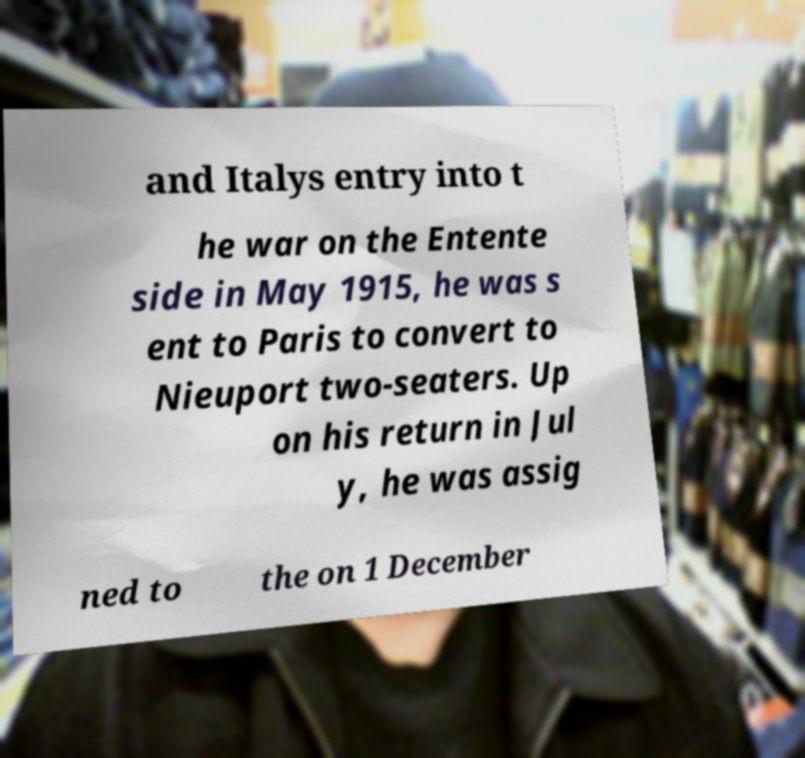I need the written content from this picture converted into text. Can you do that? and Italys entry into t he war on the Entente side in May 1915, he was s ent to Paris to convert to Nieuport two-seaters. Up on his return in Jul y, he was assig ned to the on 1 December 